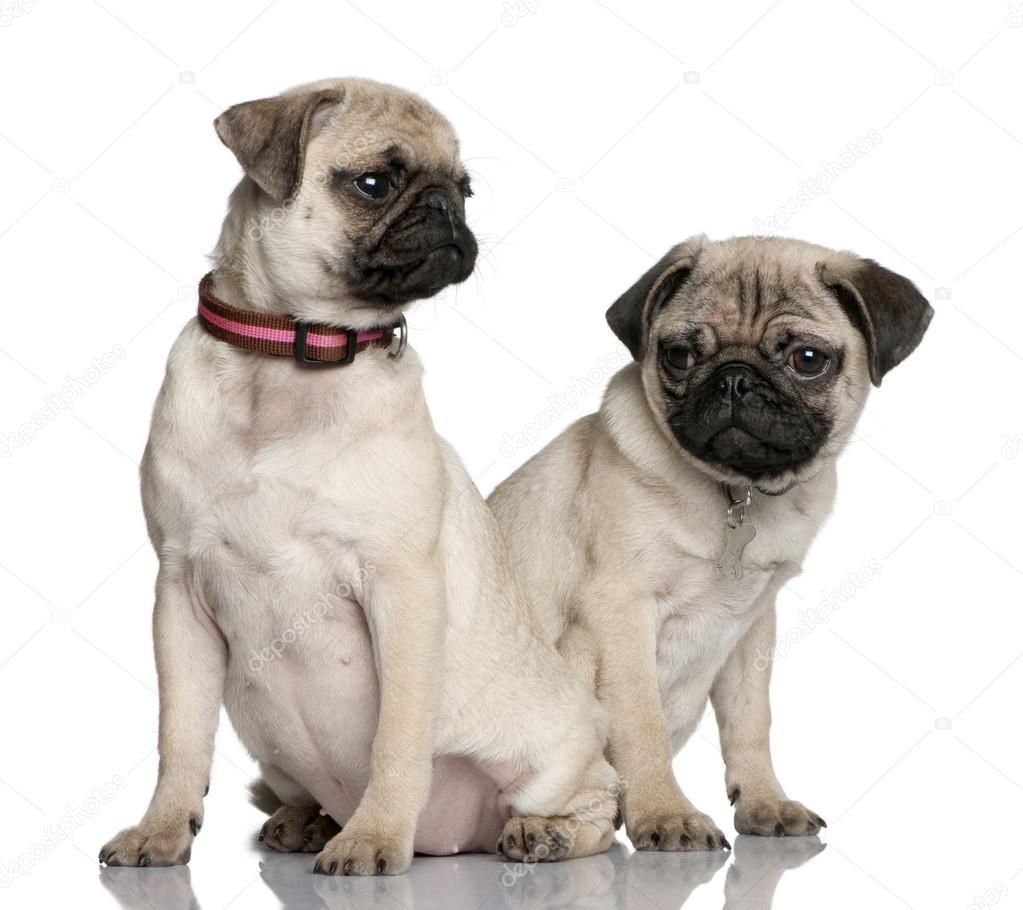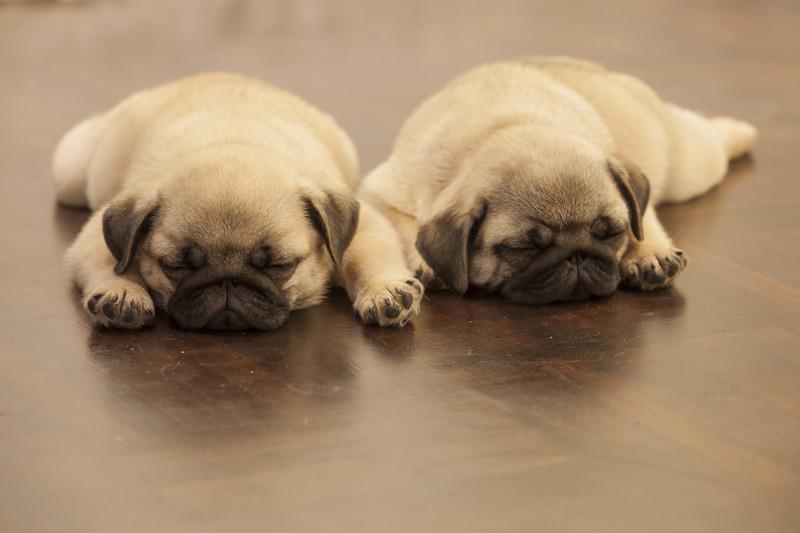The first image is the image on the left, the second image is the image on the right. Assess this claim about the two images: "Two nearly identical looking pug puppies lie flat on their bellies, side-by-side, with eyes closed.". Correct or not? Answer yes or no. Yes. The first image is the image on the left, the second image is the image on the right. Analyze the images presented: Is the assertion "One pair of dogs is sitting in front of some flowers." valid? Answer yes or no. No. 